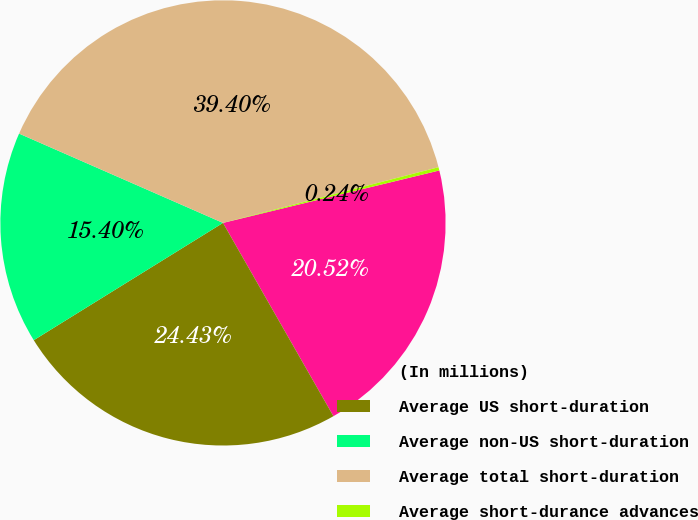<chart> <loc_0><loc_0><loc_500><loc_500><pie_chart><fcel>(In millions)<fcel>Average US short-duration<fcel>Average non-US short-duration<fcel>Average total short-duration<fcel>Average short-durance advances<nl><fcel>20.52%<fcel>24.43%<fcel>15.4%<fcel>39.4%<fcel>0.24%<nl></chart> 